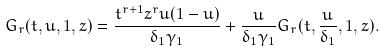<formula> <loc_0><loc_0><loc_500><loc_500>G _ { r } ( t , u , 1 , z ) = \frac { t ^ { r + 1 } z ^ { r } u ( 1 - u ) } { \delta _ { 1 } \gamma _ { 1 } } + \frac { u } { \delta _ { 1 } \gamma _ { 1 } } G _ { r } ( t , \frac { u } { \delta _ { 1 } } , 1 , z ) .</formula> 